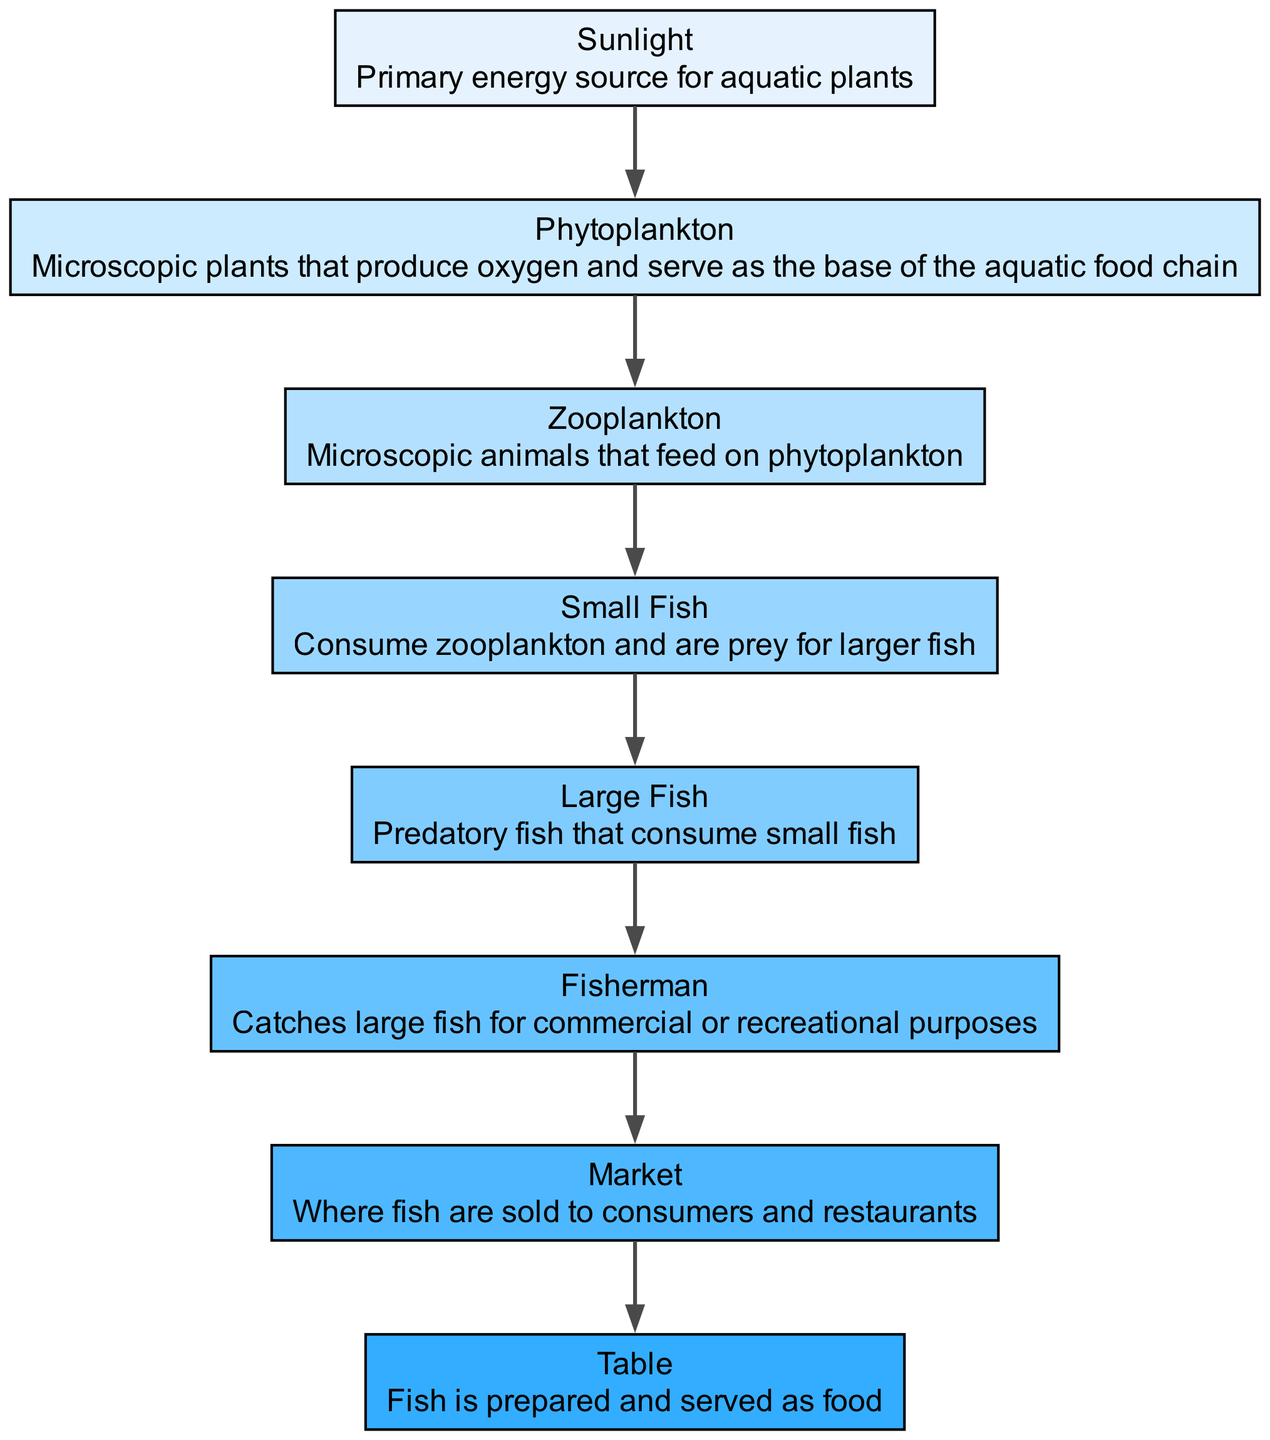What is the primary energy source for aquatic plants? The diagram identifies "Sunlight" as the primary energy source, directly related to the growth and photosynthesis of aquatic plants, which is the starting point of the food chain.
Answer: Sunlight How many nodes are present in the food chain? By counting each distinct entity listed in the diagram, we find a total of eight nodes that represent different elements in the fish food chain from the sunlight to the table.
Answer: 8 Which node feeds on phytoplankton? The diagram shows "Zooplankton" as the distinct organism that consumes phytoplankton, illustrating its role in the food chain as a consumer of primary producers.
Answer: Zooplankton What is the last step before fish is served as food? The diagram indicates that the step labelled "Table" is where the fish is prepared and served, illustrating the ultimate destination of the fish in the food chain scenario.
Answer: Table Which node is caught by the fisherman? According to the diagram, the "Large Fish" are identified as those caught by the fisherman, emphasizing their role in human consumption since they are the predators in the aquatic food chain.
Answer: Large Fish What type of fish consumes small fish? The diagram specifies that "Large Fish" are predatory fish which consume smaller fish, establishing a clear predator-prey relationship in the food chain.
Answer: Large Fish Name the entity that serves as the base of the aquatic food chain. From the diagram’s description, "Phytoplankton" functions as the foundational element of the aquatic food chain because it produces oxygen and provides energy for higher trophic levels.
Answer: Phytoplankton What is sold to consumers and restaurants? The diagram states that "Market" is where the fish are sold to consumers and restaurants, specifying a pivotal point in the fish supply chain connecting fishermen to the end-user.
Answer: Market What type of organism is zooplankton? The diagram classifies "Zooplankton" as microscopic animals that participate in the food chain by feeding on phytoplankton, depicting their position as primary consumers in the aquatic ecosystem.
Answer: Microscopic animals 